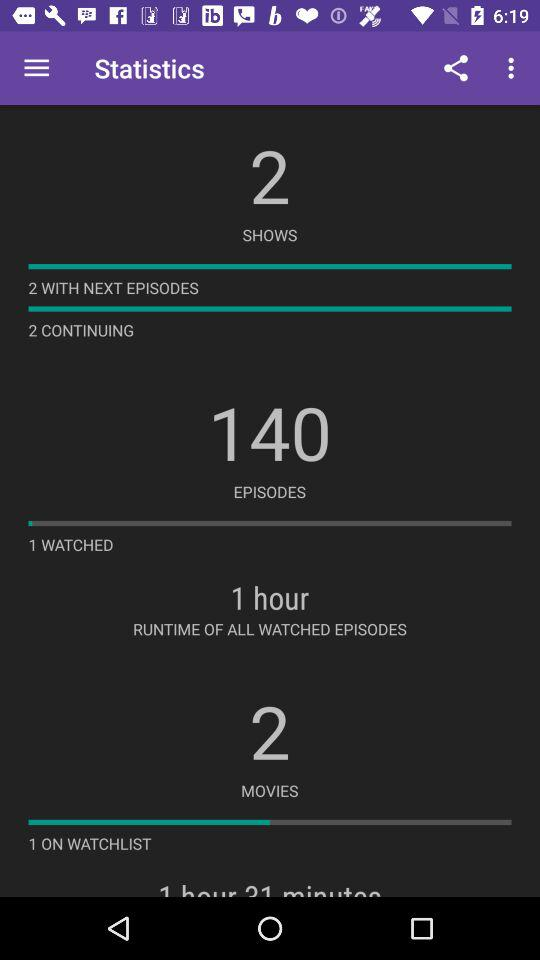What is the number of movies? The number of movies is 2. 